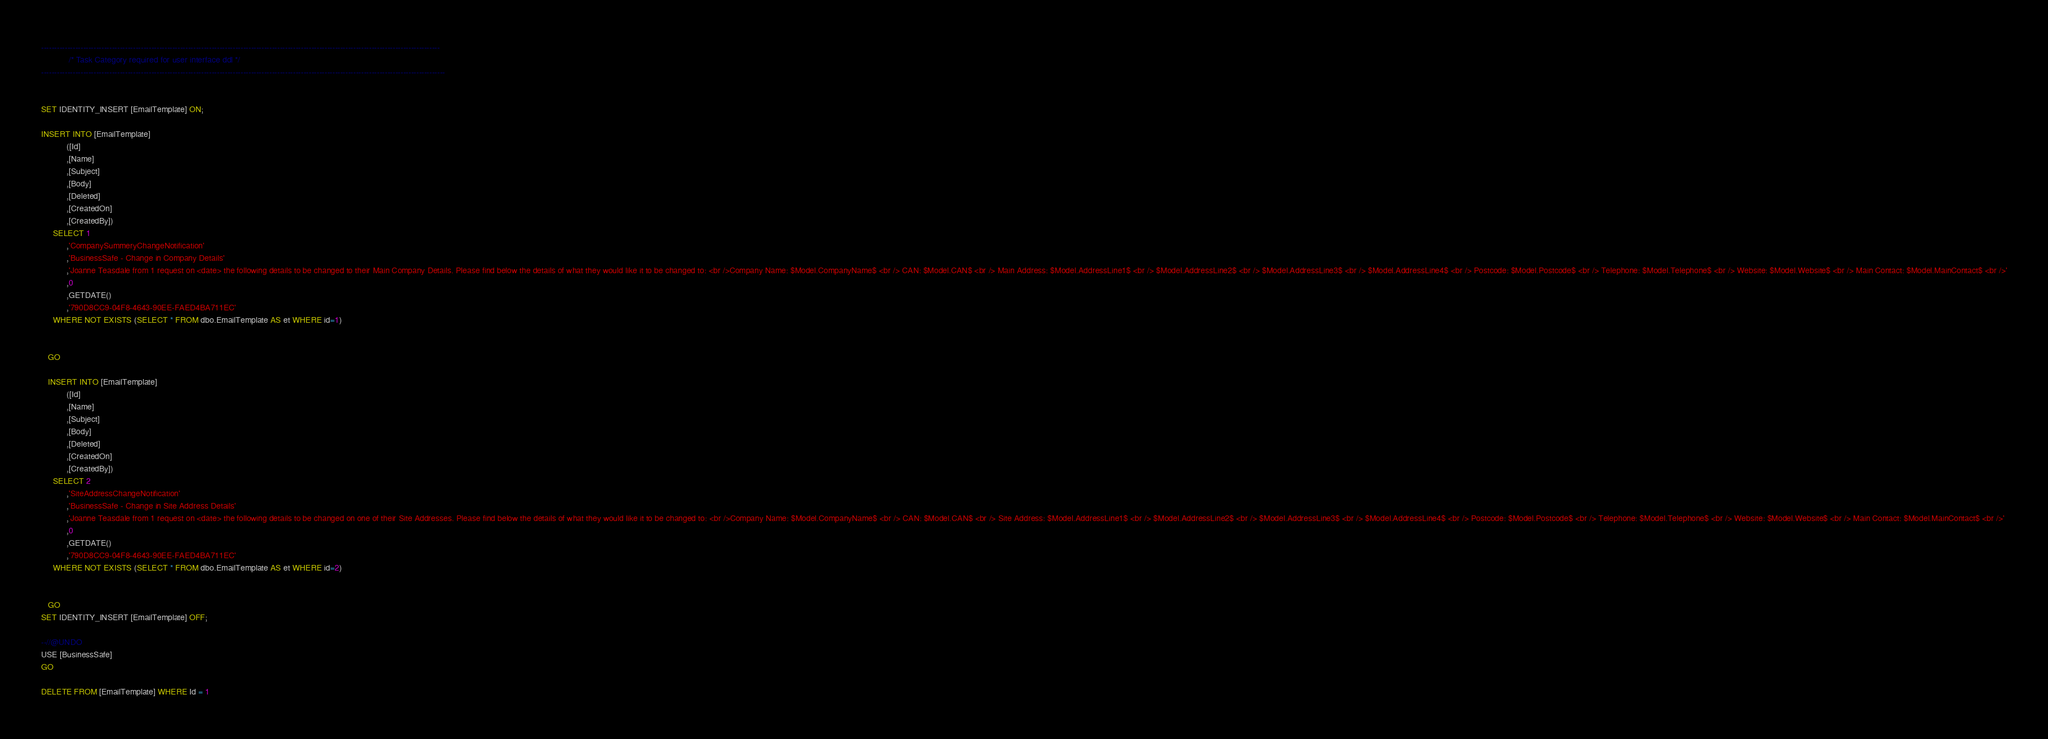Convert code to text. <code><loc_0><loc_0><loc_500><loc_500><_SQL_>--------------------------------------------------------------------------------------------------------------------------------------------------------
			/* Task Category required for user interface ddl */
----------------------------------------------------------------------------------------------------------------------------------------------------------


SET IDENTITY_INSERT [EmailTemplate] ON;

INSERT INTO [EmailTemplate]
           ([Id]
           ,[Name]
           ,[Subject]
           ,[Body]
           ,[Deleted]
           ,[CreatedOn]
           ,[CreatedBy])
     SELECT 1
           ,'CompanySummeryChangeNotification'
           ,'BusinessSafe - Change in Company Details'
           ,'Joanne Teasdale from 1 request on <date> the following details to be changed to their Main Company Details. Please find below the details of what they would like it to be changed to: <br />Company Name: $Model.CompanyName$ <br /> CAN: $Model.CAN$ <br /> Main Address: $Model.AddressLine1$ <br /> $Model.AddressLine2$ <br /> $Model.AddressLine3$ <br /> $Model.AddressLine4$ <br /> Postcode: $Model.Postcode$ <br /> Telephone: $Model.Telephone$ <br /> Website: $Model.Website$ <br /> Main Contact: $Model.MainContact$ <br />'
           ,0
           ,GETDATE()
           ,'790D8CC9-04F8-4643-90EE-FAED4BA711EC'
     WHERE NOT EXISTS (SELECT * FROM dbo.EmailTemplate AS et WHERE id=1)

                
   GO    
   
   INSERT INTO [EmailTemplate]
           ([Id]
           ,[Name]
           ,[Subject]
           ,[Body]
           ,[Deleted]
           ,[CreatedOn]
           ,[CreatedBy])
     SELECT 2
           ,'SiteAddressChangeNotification'
           ,'BusinessSafe - Change in Site Address Details'
           ,'Joanne Teasdale from 1 request on <date> the following details to be changed on one of their Site Addresses. Please find below the details of what they would like it to be changed to: <br />Company Name: $Model.CompanyName$ <br /> CAN: $Model.CAN$ <br /> Site Address: $Model.AddressLine1$ <br /> $Model.AddressLine2$ <br /> $Model.AddressLine3$ <br /> $Model.AddressLine4$ <br /> Postcode: $Model.Postcode$ <br /> Telephone: $Model.Telephone$ <br /> Website: $Model.Website$ <br /> Main Contact: $Model.MainContact$ <br />'
           ,0
           ,GETDATE()
           ,'790D8CC9-04F8-4643-90EE-FAED4BA711EC'
     WHERE NOT EXISTS (SELECT * FROM dbo.EmailTemplate AS et WHERE id=2)

                
   GO                               
SET IDENTITY_INSERT [EmailTemplate] OFF;

--//@UNDO 
USE [BusinessSafe]
GO

DELETE FROM [EmailTemplate] WHERE Id = 1

</code> 